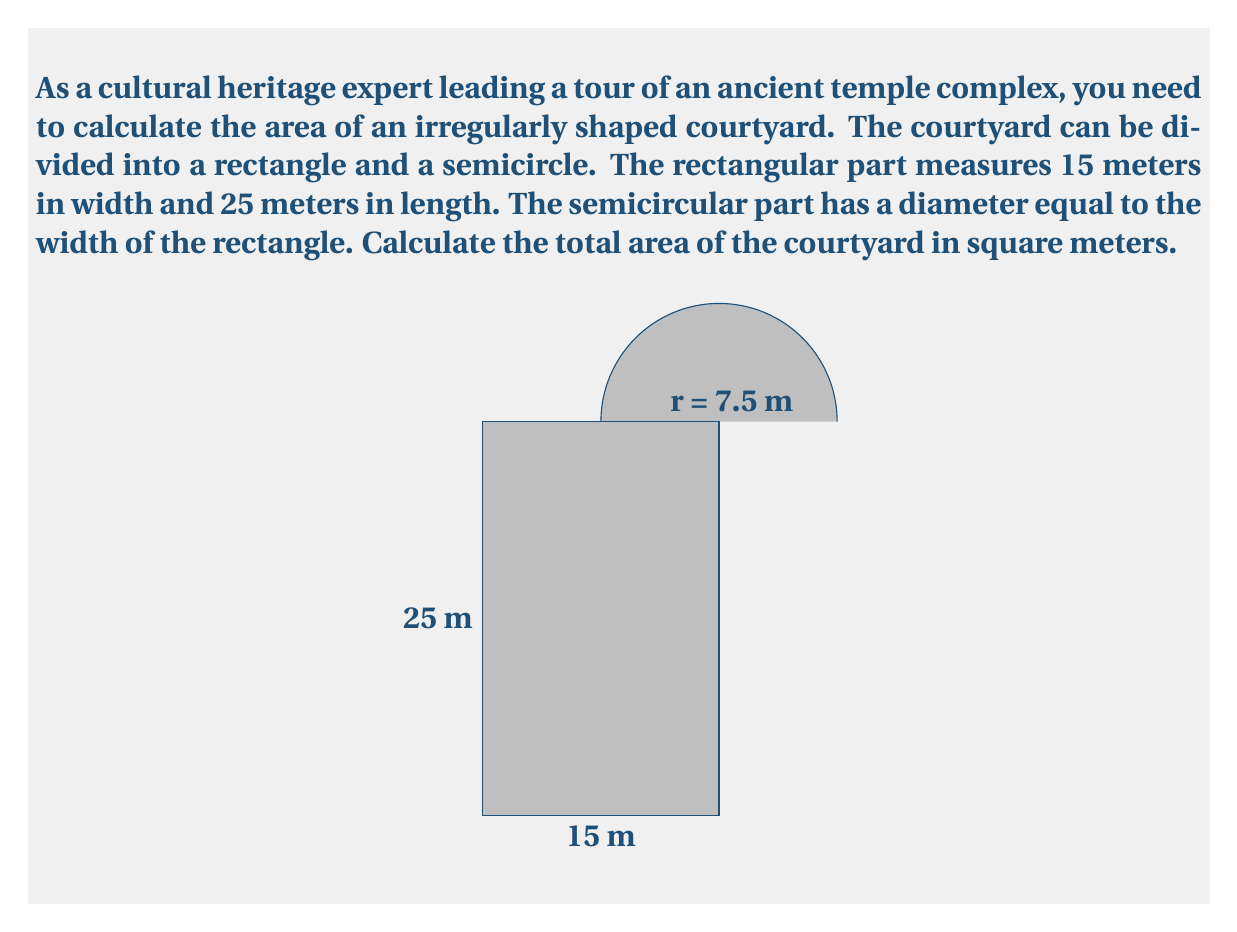Give your solution to this math problem. To solve this problem, we need to calculate the areas of the rectangular part and the semicircular part separately, then add them together.

1. Area of the rectangle:
   $$ A_r = l \times w $$
   where $l$ is the length and $w$ is the width.
   $$ A_r = 25 \text{ m} \times 15 \text{ m} = 375 \text{ m}^2 $$

2. Area of the semicircle:
   The radius of the semicircle is half the width of the rectangle: $r = 15 \text{ m} \div 2 = 7.5 \text{ m}$
   $$ A_s = \frac{1}{2} \times \pi r^2 $$
   $$ A_s = \frac{1}{2} \times \pi \times (7.5 \text{ m})^2 $$
   $$ A_s = \frac{1}{2} \times \pi \times 56.25 \text{ m}^2 \approx 88.36 \text{ m}^2 $$

3. Total area of the courtyard:
   $$ A_{\text{total}} = A_r + A_s $$
   $$ A_{\text{total}} = 375 \text{ m}^2 + 88.36 \text{ m}^2 = 463.36 \text{ m}^2 $$

Therefore, the total area of the irregularly shaped courtyard is approximately 463.36 square meters.
Answer: $463.36 \text{ m}^2$ 